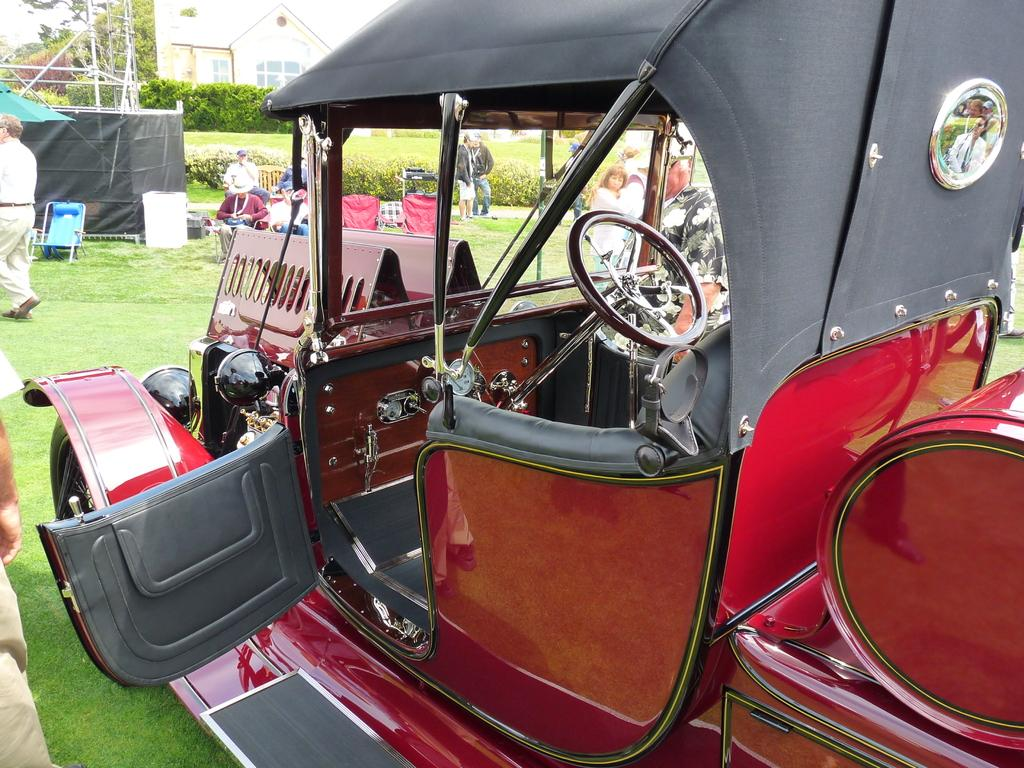What is located on the grass in the image? There is a vehicle on the grass in the image. Who or what is near the vehicle? There are people near the vehicle. What type of furniture can be seen in the image? There are chairs in the image. What can be seen in the distance in the image? There are trees and a building in the background of the image. Is there a lake visible in the image? No, there is no lake present in the image. What are the people near the vehicle doing with their hands? There is no information about the people's hands in the image, as it only provides information about their presence near the vehicle. 